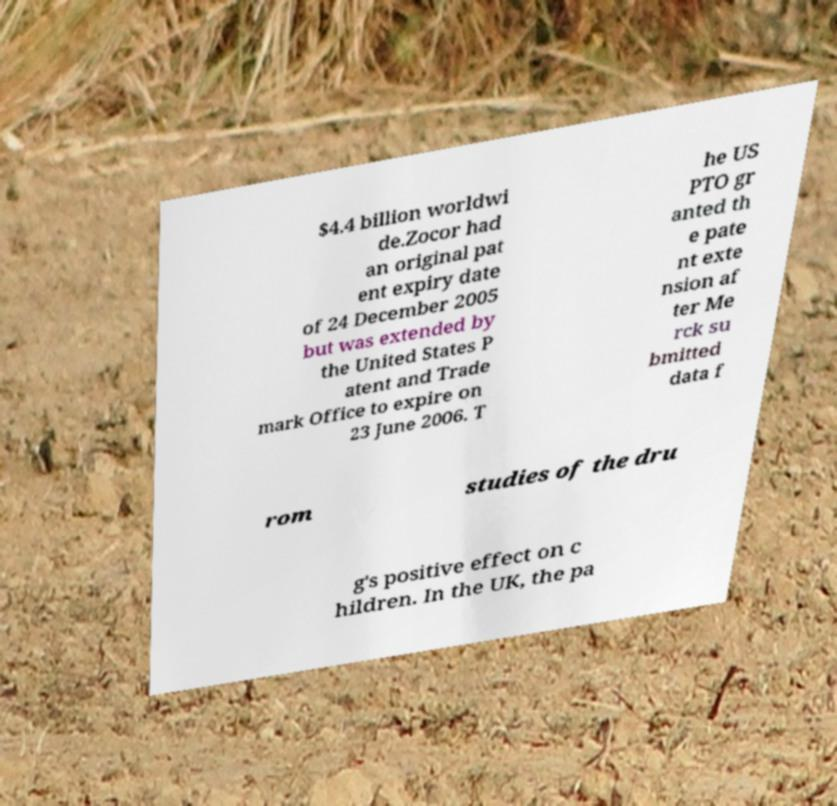What messages or text are displayed in this image? I need them in a readable, typed format. $4.4 billion worldwi de.Zocor had an original pat ent expiry date of 24 December 2005 but was extended by the United States P atent and Trade mark Office to expire on 23 June 2006. T he US PTO gr anted th e pate nt exte nsion af ter Me rck su bmitted data f rom studies of the dru g's positive effect on c hildren. In the UK, the pa 